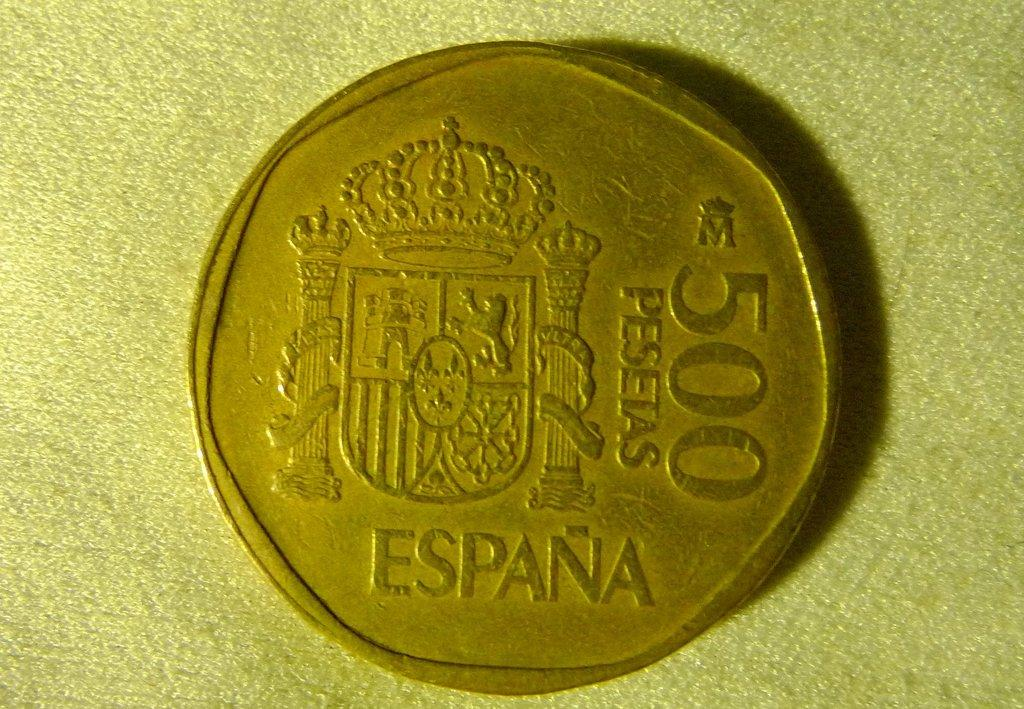What object is present on the table in the image? There is a coin on the table in the image. What type of canvas is visible in the image? There is no canvas present in the image. How many boys can be seen walking on the trail in the image? There is no trail or boys present in the image; it only features a coin on a table. 